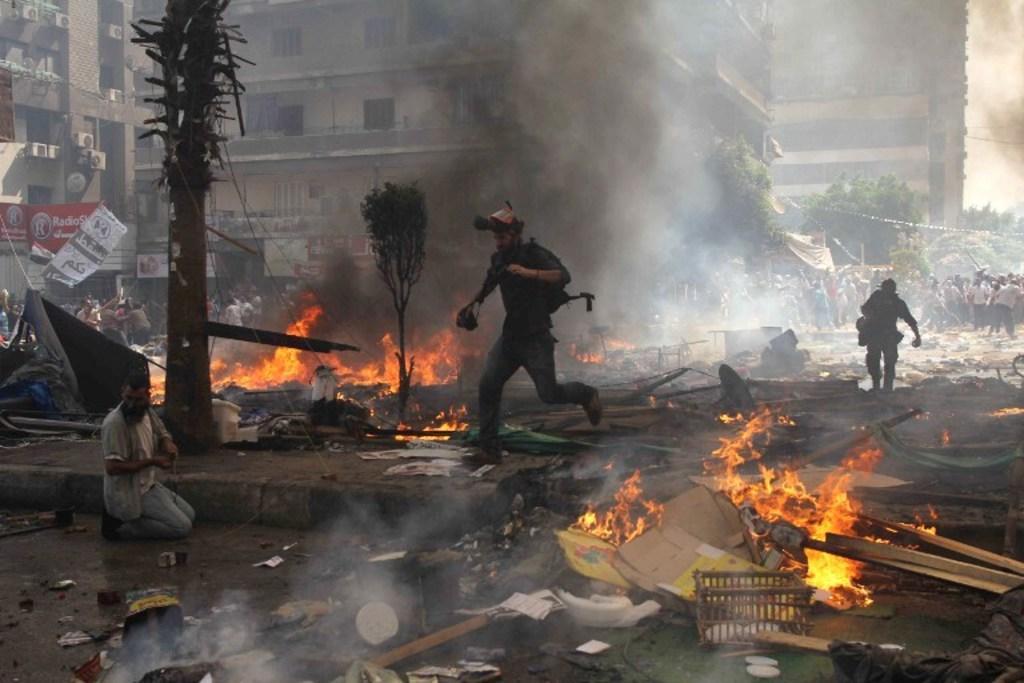In one or two sentences, can you explain what this image depicts? In this image I can see number of people, fire, number of trees, few buildings and smoke. On the left side of this image I can see number of boards and on it I can see something is written. In the front I can see number of stuffs on the ground. 